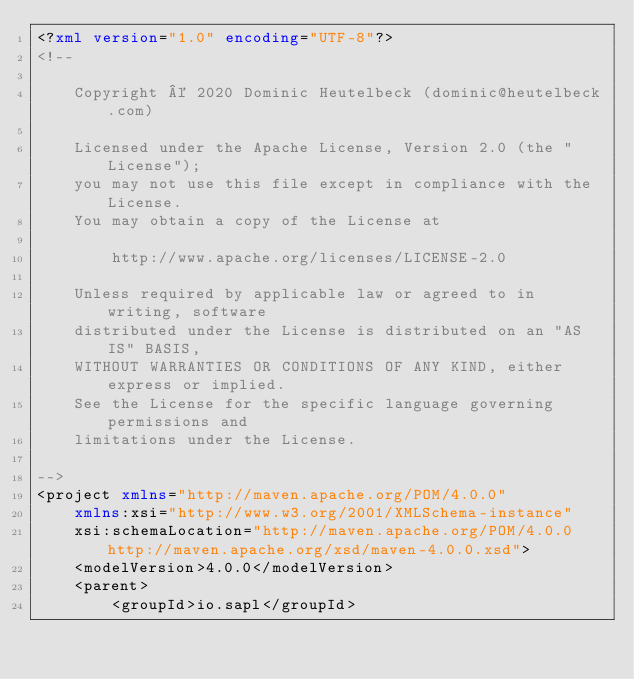<code> <loc_0><loc_0><loc_500><loc_500><_XML_><?xml version="1.0" encoding="UTF-8"?>
<!--

    Copyright © 2020 Dominic Heutelbeck (dominic@heutelbeck.com)

    Licensed under the Apache License, Version 2.0 (the "License");
    you may not use this file except in compliance with the License.
    You may obtain a copy of the License at

        http://www.apache.org/licenses/LICENSE-2.0

    Unless required by applicable law or agreed to in writing, software
    distributed under the License is distributed on an "AS IS" BASIS,
    WITHOUT WARRANTIES OR CONDITIONS OF ANY KIND, either express or implied.
    See the License for the specific language governing permissions and
    limitations under the License.

-->
<project xmlns="http://maven.apache.org/POM/4.0.0"
	xmlns:xsi="http://www.w3.org/2001/XMLSchema-instance"
	xsi:schemaLocation="http://maven.apache.org/POM/4.0.0 http://maven.apache.org/xsd/maven-4.0.0.xsd">
	<modelVersion>4.0.0</modelVersion>
	<parent>
		<groupId>io.sapl</groupId></code> 